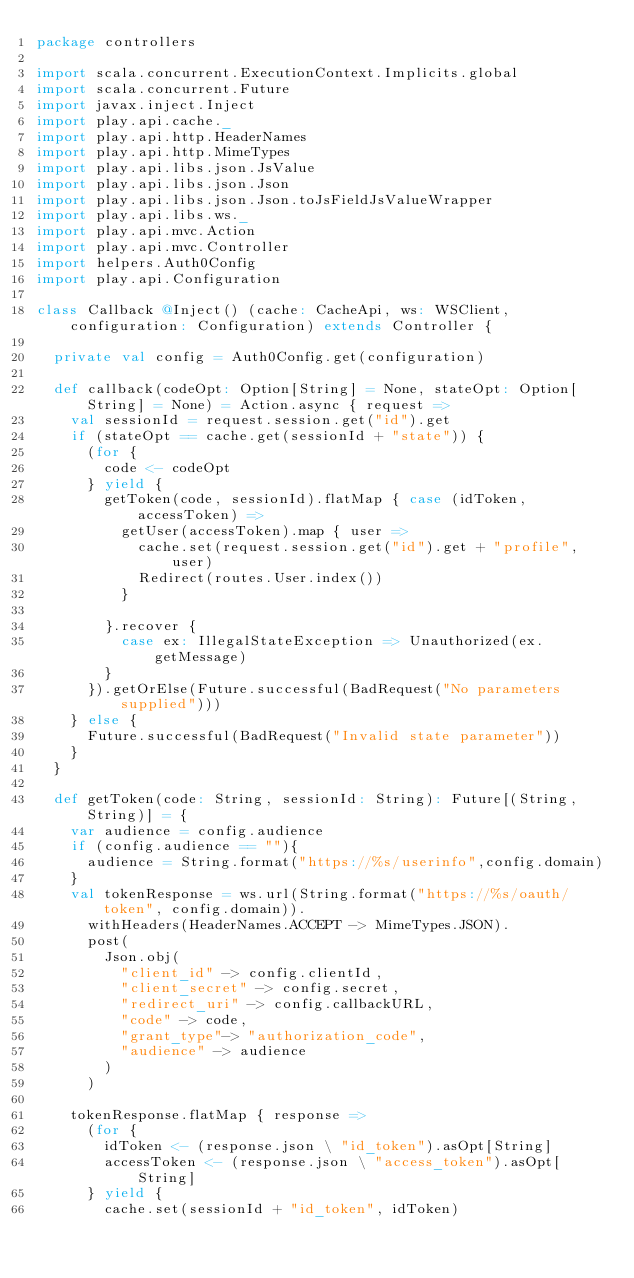Convert code to text. <code><loc_0><loc_0><loc_500><loc_500><_Scala_>package controllers

import scala.concurrent.ExecutionContext.Implicits.global
import scala.concurrent.Future
import javax.inject.Inject
import play.api.cache._
import play.api.http.HeaderNames
import play.api.http.MimeTypes
import play.api.libs.json.JsValue
import play.api.libs.json.Json
import play.api.libs.json.Json.toJsFieldJsValueWrapper
import play.api.libs.ws._
import play.api.mvc.Action
import play.api.mvc.Controller
import helpers.Auth0Config
import play.api.Configuration

class Callback @Inject() (cache: CacheApi, ws: WSClient, configuration: Configuration) extends Controller {

  private val config = Auth0Config.get(configuration)

  def callback(codeOpt: Option[String] = None, stateOpt: Option[String] = None) = Action.async { request =>
    val sessionId = request.session.get("id").get
    if (stateOpt == cache.get(sessionId + "state")) {
      (for {
        code <- codeOpt
      } yield {
        getToken(code, sessionId).flatMap { case (idToken, accessToken) =>
          getUser(accessToken).map { user =>
            cache.set(request.session.get("id").get + "profile", user)
            Redirect(routes.User.index())
          }

        }.recover {
          case ex: IllegalStateException => Unauthorized(ex.getMessage)
        }
      }).getOrElse(Future.successful(BadRequest("No parameters supplied")))
    } else {
      Future.successful(BadRequest("Invalid state parameter"))
    }
  }

  def getToken(code: String, sessionId: String): Future[(String, String)] = {
    var audience = config.audience
    if (config.audience == ""){
      audience = String.format("https://%s/userinfo",config.domain)
    }
    val tokenResponse = ws.url(String.format("https://%s/oauth/token", config.domain)).
      withHeaders(HeaderNames.ACCEPT -> MimeTypes.JSON).
      post(
        Json.obj(
          "client_id" -> config.clientId,
          "client_secret" -> config.secret,
          "redirect_uri" -> config.callbackURL,
          "code" -> code,
          "grant_type"-> "authorization_code",
          "audience" -> audience
        )
      )

    tokenResponse.flatMap { response =>
      (for {
        idToken <- (response.json \ "id_token").asOpt[String]
        accessToken <- (response.json \ "access_token").asOpt[String]
      } yield {
        cache.set(sessionId + "id_token", idToken)</code> 